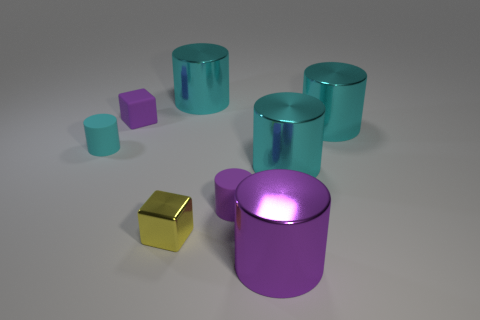How many cyan cylinders must be subtracted to get 1 cyan cylinders? 3 Add 1 rubber cylinders. How many objects exist? 9 Subtract all small matte cylinders. How many cylinders are left? 4 Subtract all gray spheres. How many purple cylinders are left? 2 Subtract 1 cylinders. How many cylinders are left? 5 Subtract all purple cylinders. How many cylinders are left? 4 Subtract all cylinders. How many objects are left? 2 Subtract all green cylinders. Subtract all brown blocks. How many cylinders are left? 6 Subtract all red metal cylinders. Subtract all tiny cyan rubber cylinders. How many objects are left? 7 Add 7 large purple shiny cylinders. How many large purple shiny cylinders are left? 8 